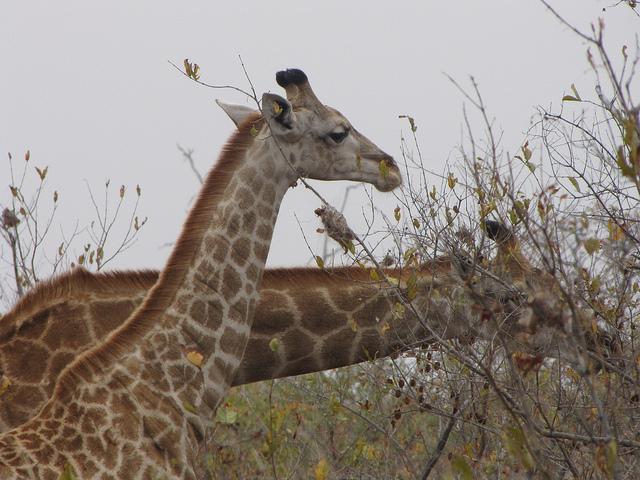What are the animals doing?
Give a very brief answer. Eating. Are these animals reptiles?
Keep it brief. No. What are the animals eating?
Short answer required. Leaves. 